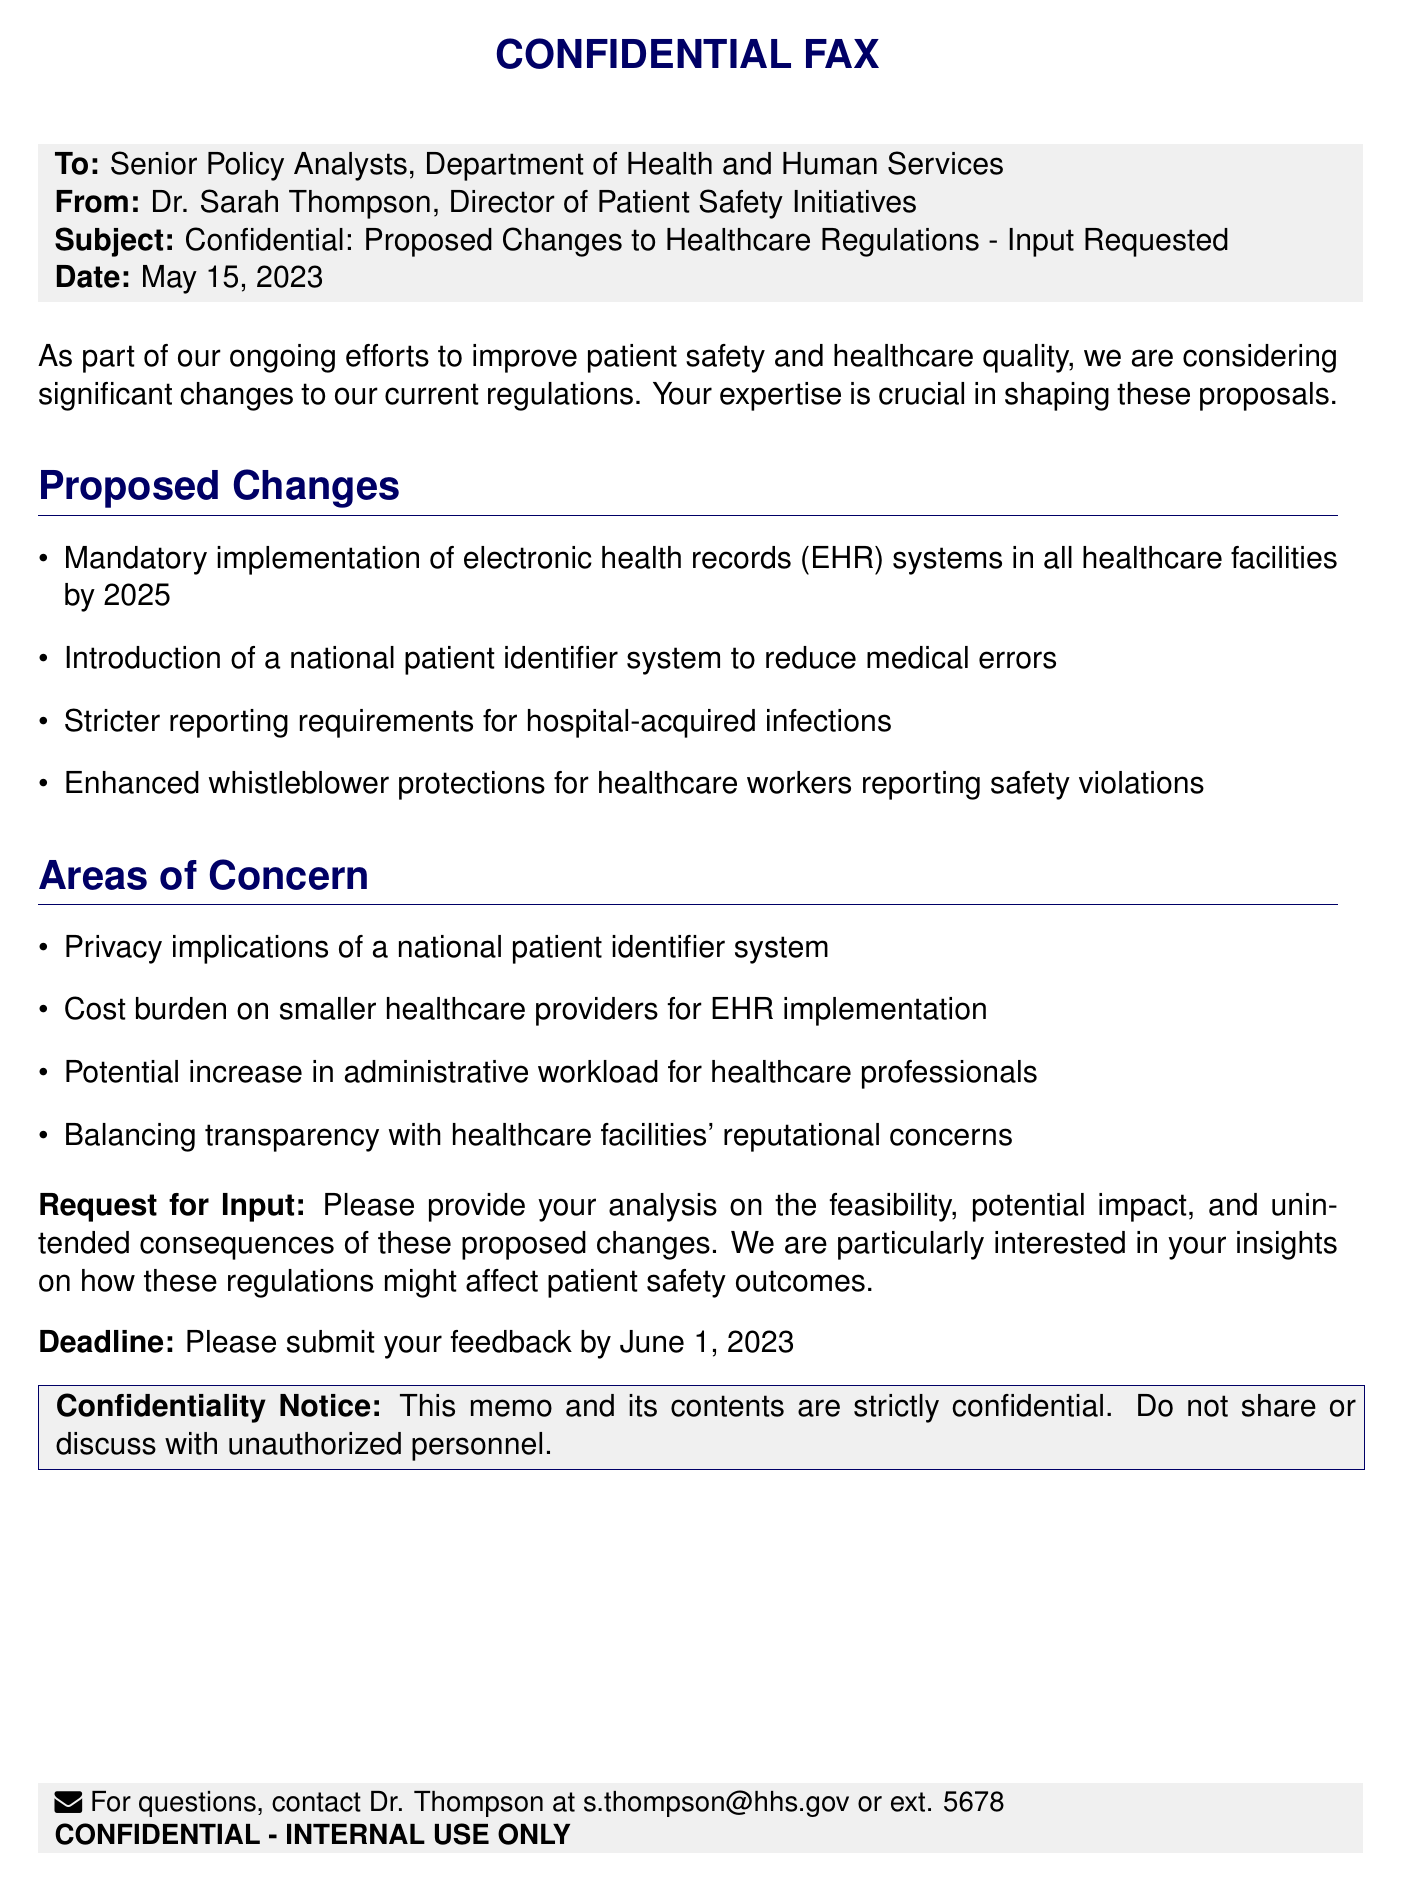what is the date of the fax? The date of the fax is indicated at the top of the document, which is May 15, 2023.
Answer: May 15, 2023 who is the sender of the fax? The sender is listed at the top of the document as Dr. Sarah Thompson, Director of Patient Safety Initiatives.
Answer: Dr. Sarah Thompson what is the subject of the fax? The subject line summarizes the main topic of the document, which is "Confidential: Proposed Changes to Healthcare Regulations - Input Requested."
Answer: Proposed Changes to Healthcare Regulations - Input Requested what is the deadline for feedback? The deadline for submitting feedback is given towards the end of the document, which is June 1, 2023.
Answer: June 1, 2023 what is one proposed change mentioned in the memo? The memo lists several proposed changes; one of them is the "Mandatory implementation of electronic health records (EHR) systems in all healthcare facilities by 2025."
Answer: Mandatory implementation of electronic health records what is a concern regarding the national patient identifier system? One of the areas of concern highlighted in the document is "Privacy implications of a national patient identifier system."
Answer: Privacy implications what is the purpose of the fax? The purpose of the fax is to request input and feedback from senior policy analysts on proposed changes to healthcare regulations.
Answer: Request input and feedback what is the confidentiality notice about? The confidentiality notice emphasizes that the memo and its contents are strictly confidential and should not be shared with unauthorized personnel.
Answer: Strictly confidential what type of document is this? The document is categorized as a fax, as indicated at the top.
Answer: Fax 